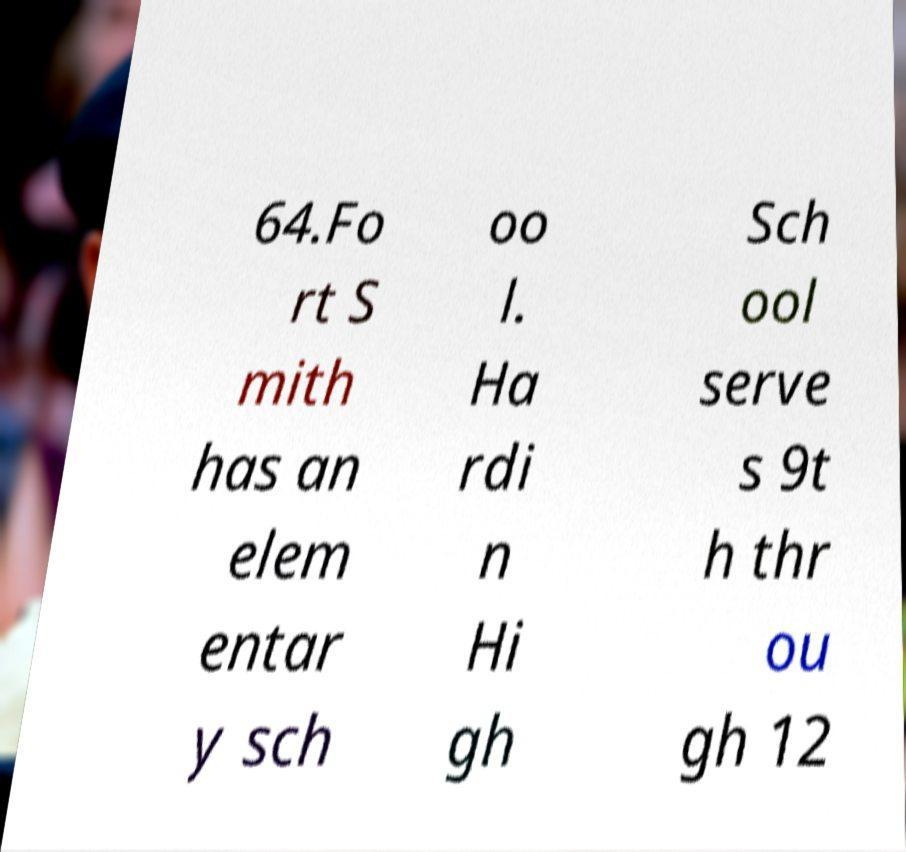There's text embedded in this image that I need extracted. Can you transcribe it verbatim? 64.Fo rt S mith has an elem entar y sch oo l. Ha rdi n Hi gh Sch ool serve s 9t h thr ou gh 12 